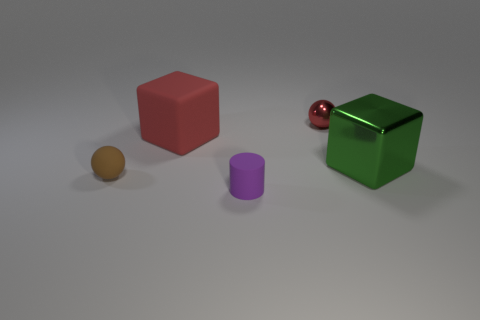Does the shiny object in front of the tiny metallic thing have the same shape as the large red thing?
Your response must be concise. Yes. Are there any large red rubber objects of the same shape as the green metallic thing?
Ensure brevity in your answer.  Yes. Is the shape of the red metal thing the same as the brown matte object?
Offer a very short reply. Yes. Is the size of the red object on the left side of the purple matte object the same as the cube in front of the large rubber cube?
Offer a very short reply. Yes. What number of objects are either tiny spheres that are right of the brown matte sphere or big green objects?
Provide a short and direct response. 2. Is the number of tiny metallic balls less than the number of things?
Your answer should be compact. Yes. The metal object on the right side of the sphere that is behind the matte thing that is behind the brown matte sphere is what shape?
Ensure brevity in your answer.  Cube. What is the shape of the metal object that is the same color as the rubber block?
Keep it short and to the point. Sphere. Is there a thing?
Make the answer very short. Yes. Do the cylinder and the sphere behind the tiny brown rubber ball have the same size?
Your answer should be very brief. Yes. 